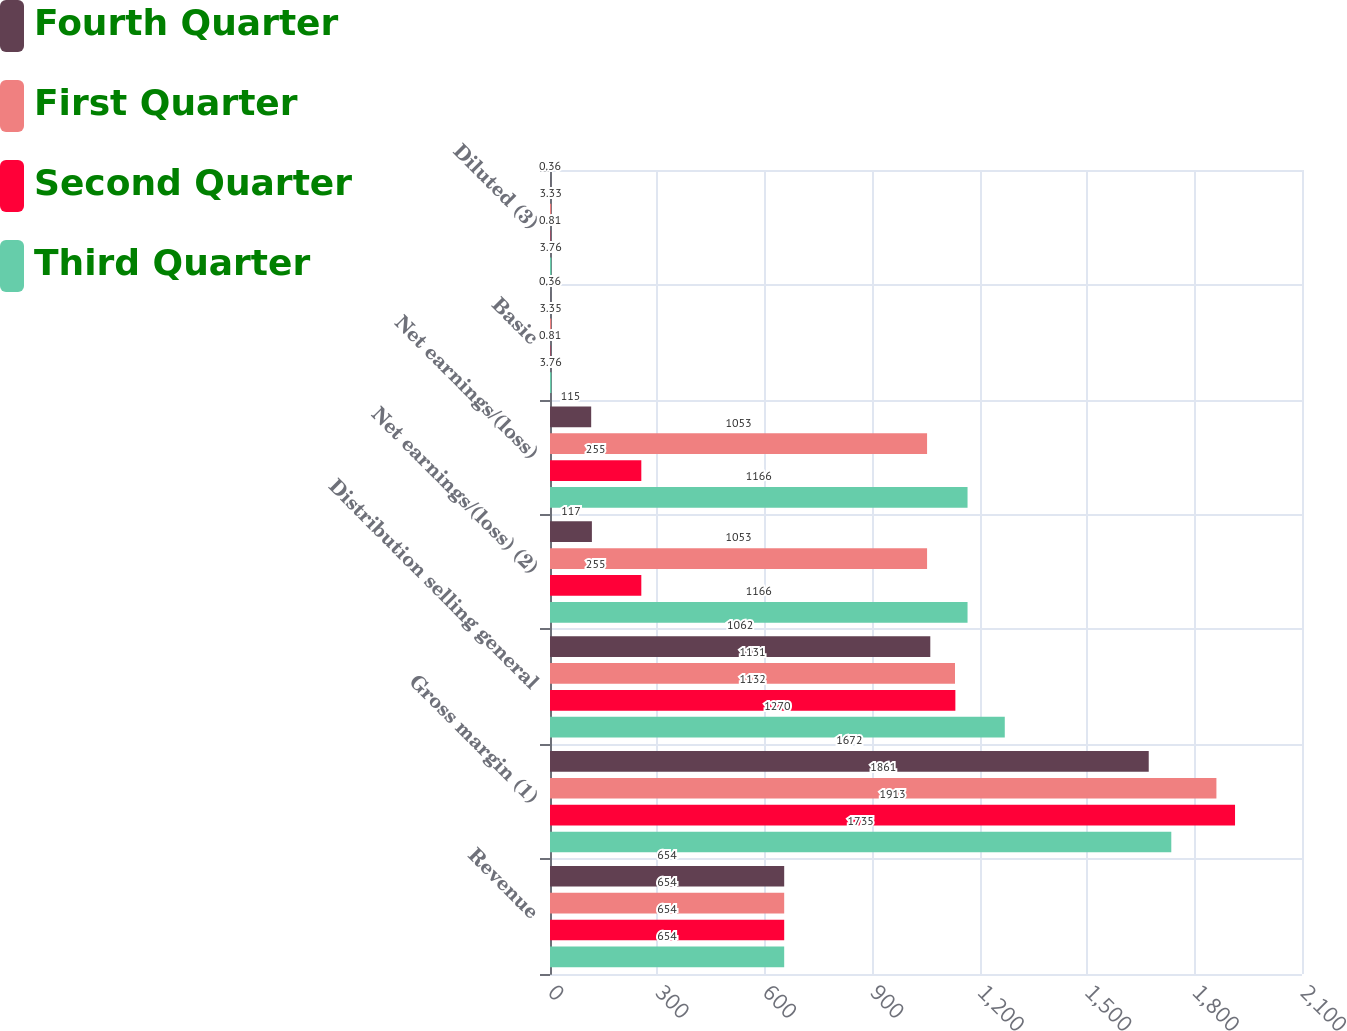<chart> <loc_0><loc_0><loc_500><loc_500><stacked_bar_chart><ecel><fcel>Revenue<fcel>Gross margin (1)<fcel>Distribution selling general<fcel>Net earnings/(loss) (2)<fcel>Net earnings/(loss)<fcel>Basic<fcel>Diluted (3)<nl><fcel>Fourth Quarter<fcel>654<fcel>1672<fcel>1062<fcel>117<fcel>115<fcel>0.36<fcel>0.36<nl><fcel>First Quarter<fcel>654<fcel>1861<fcel>1131<fcel>1053<fcel>1053<fcel>3.35<fcel>3.33<nl><fcel>Second Quarter<fcel>654<fcel>1913<fcel>1132<fcel>255<fcel>255<fcel>0.81<fcel>0.81<nl><fcel>Third Quarter<fcel>654<fcel>1735<fcel>1270<fcel>1166<fcel>1166<fcel>3.76<fcel>3.76<nl></chart> 